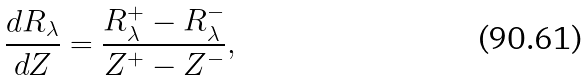<formula> <loc_0><loc_0><loc_500><loc_500>\frac { d R _ { \lambda } } { d Z } = \frac { R ^ { + } _ { \lambda } - R ^ { - } _ { \lambda } } { Z ^ { + } - Z ^ { - } } ,</formula> 